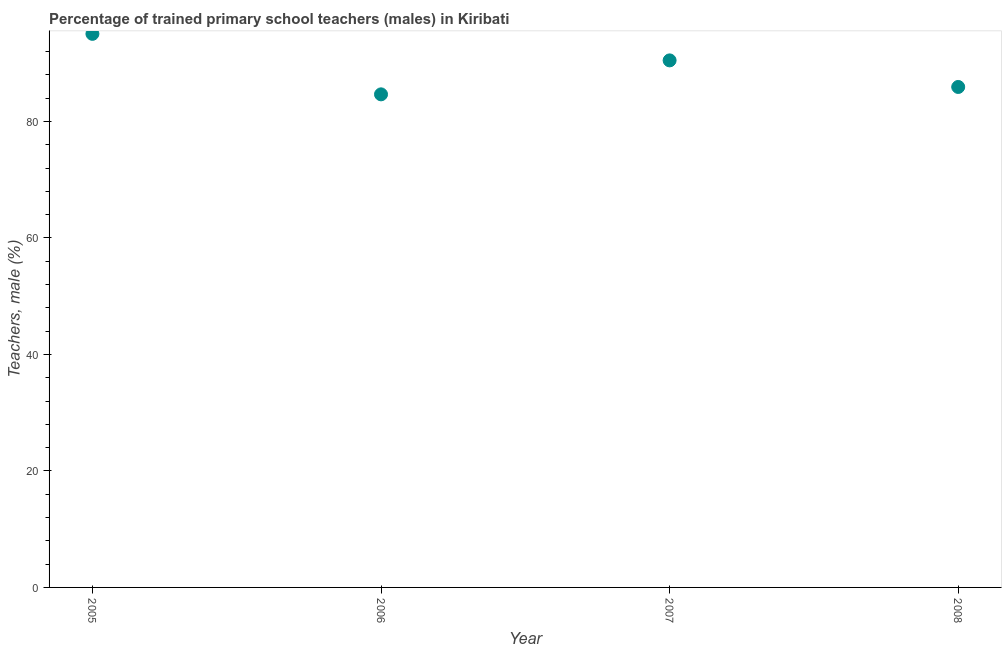What is the percentage of trained male teachers in 2006?
Make the answer very short. 84.66. Across all years, what is the maximum percentage of trained male teachers?
Provide a succinct answer. 95.05. Across all years, what is the minimum percentage of trained male teachers?
Your response must be concise. 84.66. In which year was the percentage of trained male teachers maximum?
Provide a short and direct response. 2005. What is the sum of the percentage of trained male teachers?
Ensure brevity in your answer.  356.14. What is the difference between the percentage of trained male teachers in 2005 and 2008?
Your response must be concise. 9.12. What is the average percentage of trained male teachers per year?
Provide a short and direct response. 89.04. What is the median percentage of trained male teachers?
Keep it short and to the point. 88.21. In how many years, is the percentage of trained male teachers greater than 20 %?
Offer a very short reply. 4. Do a majority of the years between 2007 and 2005 (inclusive) have percentage of trained male teachers greater than 64 %?
Keep it short and to the point. No. What is the ratio of the percentage of trained male teachers in 2005 to that in 2007?
Provide a short and direct response. 1.05. Is the difference between the percentage of trained male teachers in 2006 and 2007 greater than the difference between any two years?
Offer a very short reply. No. What is the difference between the highest and the second highest percentage of trained male teachers?
Ensure brevity in your answer.  4.56. Is the sum of the percentage of trained male teachers in 2005 and 2006 greater than the maximum percentage of trained male teachers across all years?
Provide a short and direct response. Yes. What is the difference between the highest and the lowest percentage of trained male teachers?
Offer a very short reply. 10.39. How many dotlines are there?
Your answer should be very brief. 1. What is the difference between two consecutive major ticks on the Y-axis?
Provide a short and direct response. 20. Are the values on the major ticks of Y-axis written in scientific E-notation?
Make the answer very short. No. Does the graph contain grids?
Your response must be concise. No. What is the title of the graph?
Provide a short and direct response. Percentage of trained primary school teachers (males) in Kiribati. What is the label or title of the X-axis?
Make the answer very short. Year. What is the label or title of the Y-axis?
Offer a terse response. Teachers, male (%). What is the Teachers, male (%) in 2005?
Offer a very short reply. 95.05. What is the Teachers, male (%) in 2006?
Give a very brief answer. 84.66. What is the Teachers, male (%) in 2007?
Ensure brevity in your answer.  90.5. What is the Teachers, male (%) in 2008?
Your answer should be compact. 85.93. What is the difference between the Teachers, male (%) in 2005 and 2006?
Provide a short and direct response. 10.39. What is the difference between the Teachers, male (%) in 2005 and 2007?
Your answer should be compact. 4.56. What is the difference between the Teachers, male (%) in 2005 and 2008?
Your answer should be compact. 9.12. What is the difference between the Teachers, male (%) in 2006 and 2007?
Offer a very short reply. -5.83. What is the difference between the Teachers, male (%) in 2006 and 2008?
Ensure brevity in your answer.  -1.27. What is the difference between the Teachers, male (%) in 2007 and 2008?
Give a very brief answer. 4.56. What is the ratio of the Teachers, male (%) in 2005 to that in 2006?
Your response must be concise. 1.12. What is the ratio of the Teachers, male (%) in 2005 to that in 2008?
Make the answer very short. 1.11. What is the ratio of the Teachers, male (%) in 2006 to that in 2007?
Ensure brevity in your answer.  0.94. What is the ratio of the Teachers, male (%) in 2007 to that in 2008?
Provide a succinct answer. 1.05. 